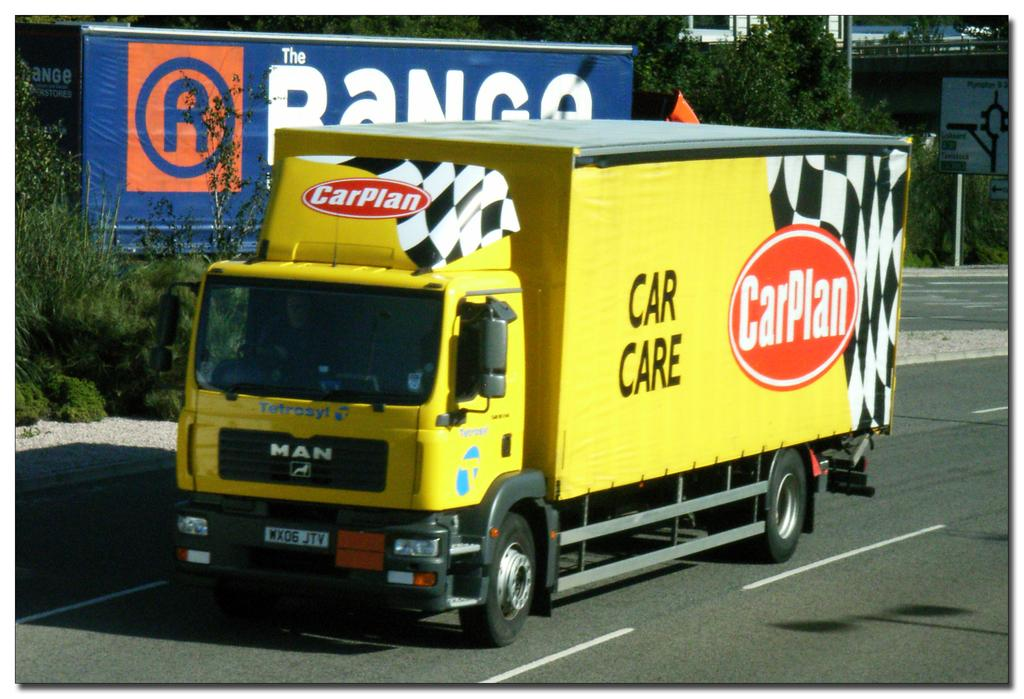What is the main subject of the image? There is a vehicle in the image. Where is the vehicle located? The vehicle is on the road. What can be seen in the background of the image? There are trees, buildings, and boards in the background of the image. How many toothbrushes can be seen hanging from the trees in the image? There are no toothbrushes visible in the image, as it features a vehicle on the road with trees, buildings, and boards in the background. 